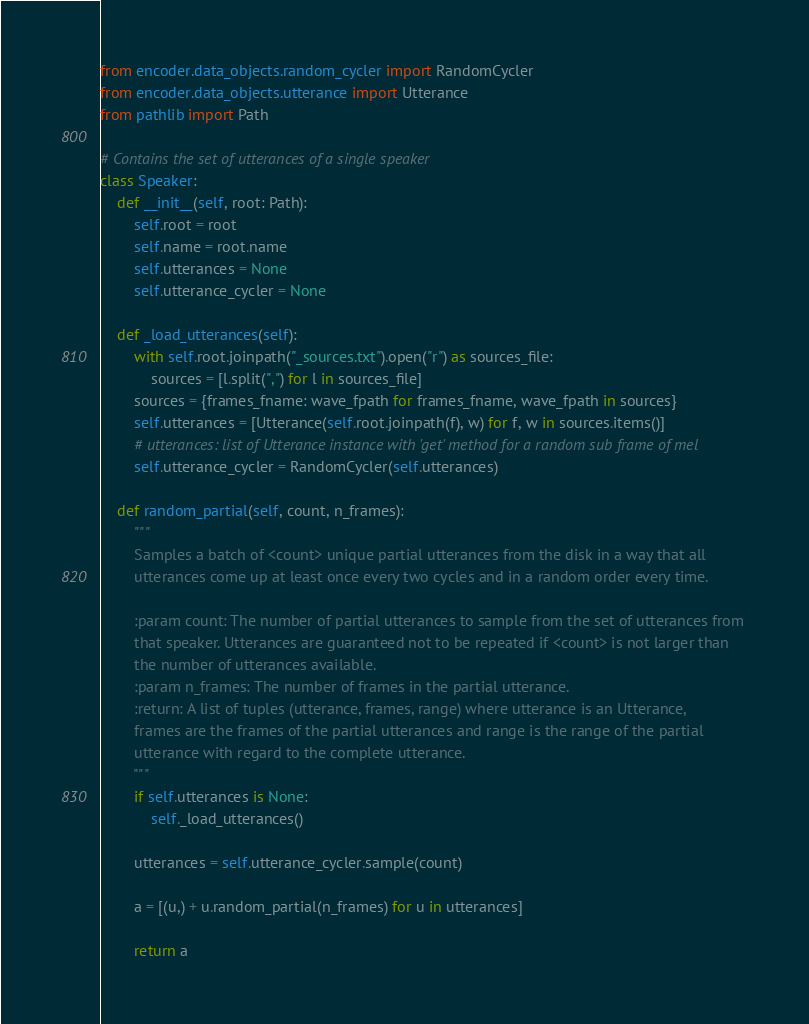Convert code to text. <code><loc_0><loc_0><loc_500><loc_500><_Python_>from encoder.data_objects.random_cycler import RandomCycler
from encoder.data_objects.utterance import Utterance
from pathlib import Path

# Contains the set of utterances of a single speaker
class Speaker:
    def __init__(self, root: Path):
        self.root = root
        self.name = root.name
        self.utterances = None
        self.utterance_cycler = None
        
    def _load_utterances(self):
        with self.root.joinpath("_sources.txt").open("r") as sources_file:
            sources = [l.split(",") for l in sources_file]
        sources = {frames_fname: wave_fpath for frames_fname, wave_fpath in sources}
        self.utterances = [Utterance(self.root.joinpath(f), w) for f, w in sources.items()]
        # utterances: list of Utterance instance with 'get' method for a random sub frame of mel
        self.utterance_cycler = RandomCycler(self.utterances)
               
    def random_partial(self, count, n_frames):
        """
        Samples a batch of <count> unique partial utterances from the disk in a way that all 
        utterances come up at least once every two cycles and in a random order every time.
        
        :param count: The number of partial utterances to sample from the set of utterances from 
        that speaker. Utterances are guaranteed not to be repeated if <count> is not larger than 
        the number of utterances available.
        :param n_frames: The number of frames in the partial utterance.
        :return: A list of tuples (utterance, frames, range) where utterance is an Utterance, 
        frames are the frames of the partial utterances and range is the range of the partial 
        utterance with regard to the complete utterance.
        """
        if self.utterances is None:
            self._load_utterances()

        utterances = self.utterance_cycler.sample(count)

        a = [(u,) + u.random_partial(n_frames) for u in utterances]

        return a
</code> 